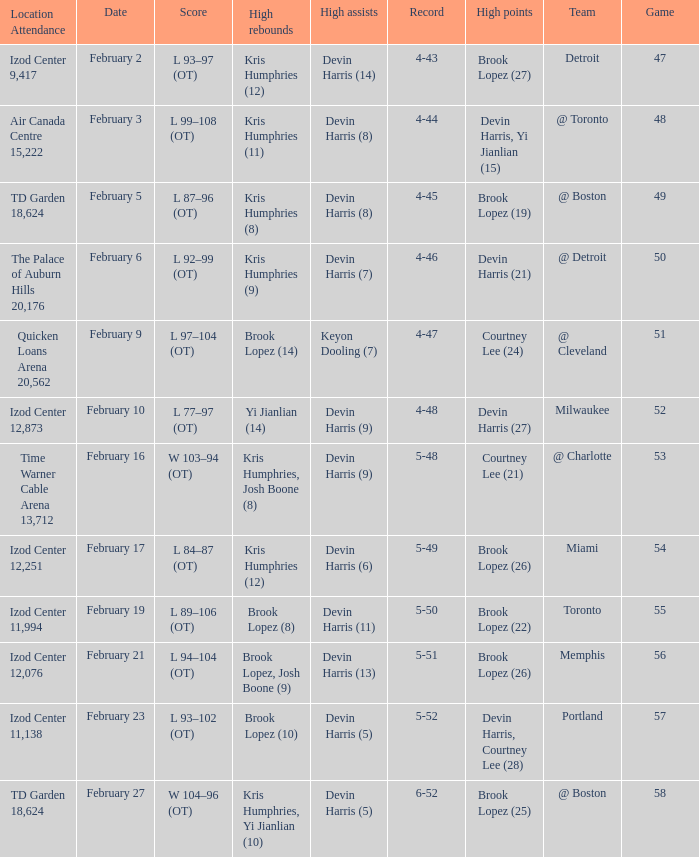What team was the game on February 27 played against? @ Boston. 